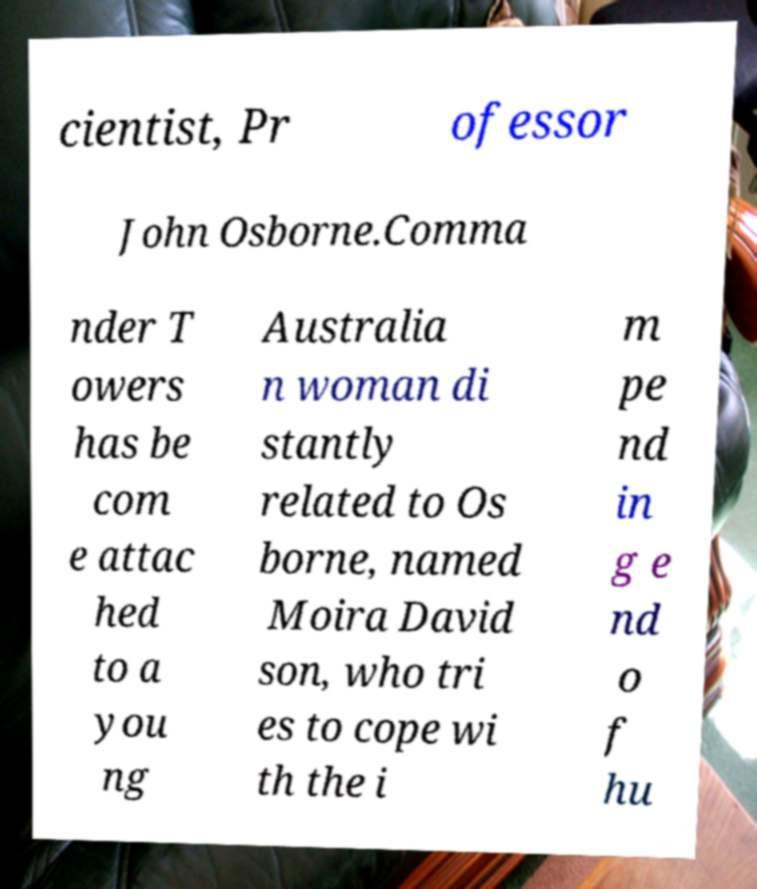What messages or text are displayed in this image? I need them in a readable, typed format. cientist, Pr ofessor John Osborne.Comma nder T owers has be com e attac hed to a you ng Australia n woman di stantly related to Os borne, named Moira David son, who tri es to cope wi th the i m pe nd in g e nd o f hu 